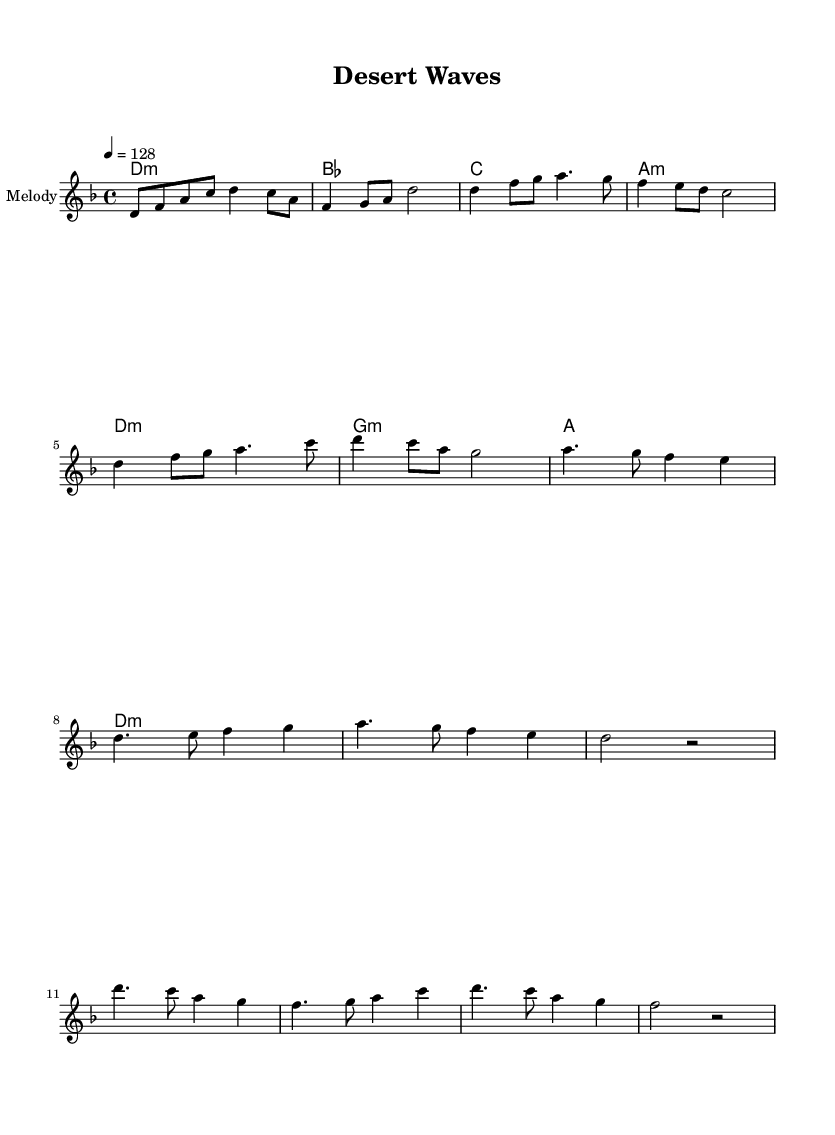What is the key signature of this music? The key signature is D minor, which has one flat (B flat) in its scale. This can be determined by looking at the key signature at the beginning of the staff, which indicates the tonality of the piece.
Answer: D minor What is the time signature of the piece? The time signature is 4/4, which means there are four beats in each measure and the quarter note gets one beat. This can be found at the beginning of the sheet music, indicated right next to the key signature.
Answer: 4/4 What is the tempo marking of this composition? The tempo marking is Quarter Note = 128, indicating that there are 128 beats per minute. This is stated at the beginning of the score and affects the overall energy of the piece.
Answer: 128 How many measures are there in the chorus section? The chorus section consists of four measures. You can identify this by locating the chorus section in the sheet music, which is typically marked and counting the measures from start to finish.
Answer: 4 What is the last note of the pre-chorus? The last note of the pre-chorus is a rest, which indicates silence at the end of that section. This can be seen at the end of the pre-chorus, where the notation specifically shows a rest symbol instead of a note.
Answer: rest Which chord follows the D minor chord in the progression? The chord that follows the D minor chord is B flat major. This can be inferred by examining the chord progression written beneath the melody and tracking the sequence of chords presented.
Answer: B flat major 